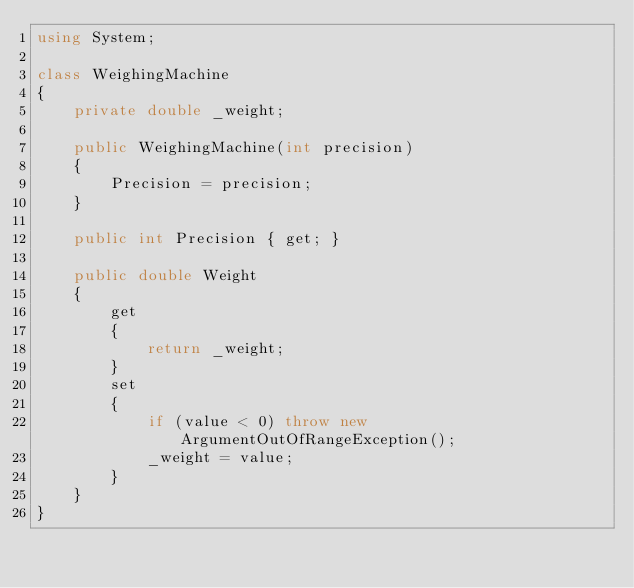Convert code to text. <code><loc_0><loc_0><loc_500><loc_500><_C#_>using System;

class WeighingMachine
{
    private double _weight;

    public WeighingMachine(int precision)
    {
        Precision = precision;
    }

    public int Precision { get; }

    public double Weight
    {
        get
        {
            return _weight;
        }
        set
        {
            if (value < 0) throw new ArgumentOutOfRangeException();
            _weight = value;
        }
    }
}
</code> 